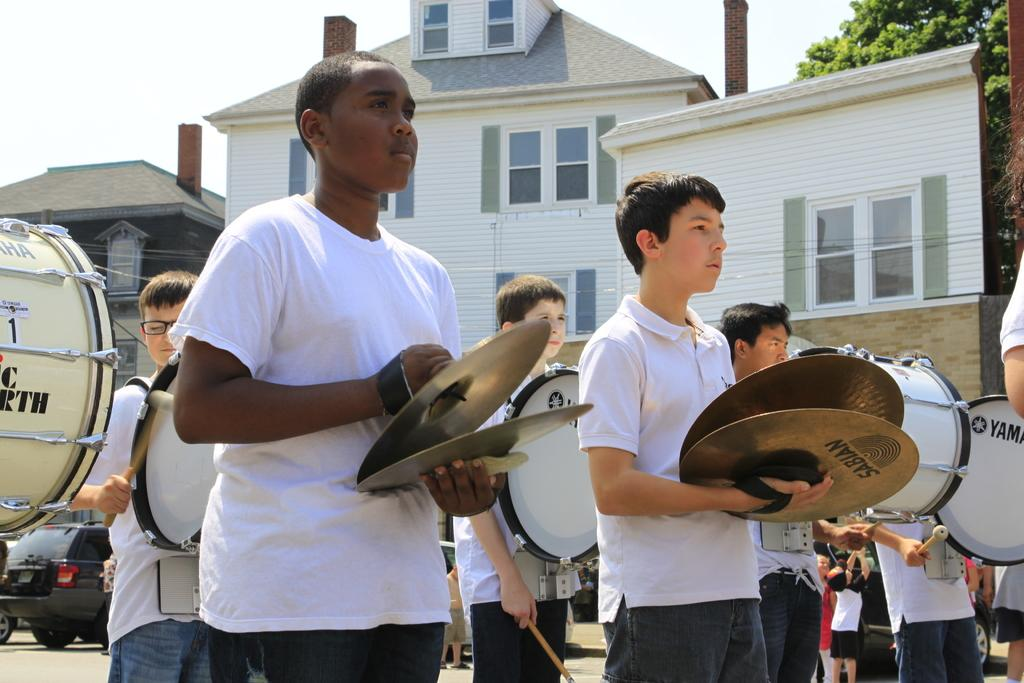How many people are in the image? There is a group of people in the image, but the exact number is not specified. What are some of the people doing in the image? Some people are holding musical instruments in the image. What can be seen in the background of the image? There are vehicles, trees, and buildings in the background of the image. What type of comb is being used by the person in the image? There is no comb present in the image. 